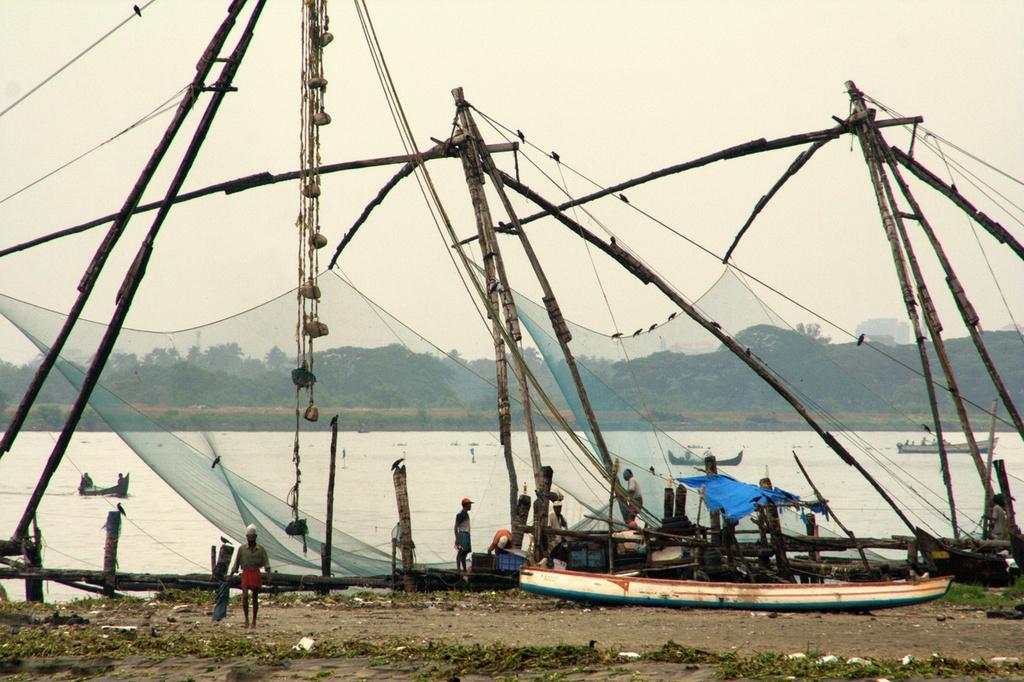What are the people in the image doing? The people in the image are standing on the ground. What can be seen in the water in the image? There are ships in the water in the image. What type of natural scenery is visible in the background of the image? There are trees visible in the background of the image. What type of door can be seen in the image? There is no door present in the image. What is the voice of the person in the image saying? There are no people speaking in the image, so it is not possible to determine what they might be saying. 